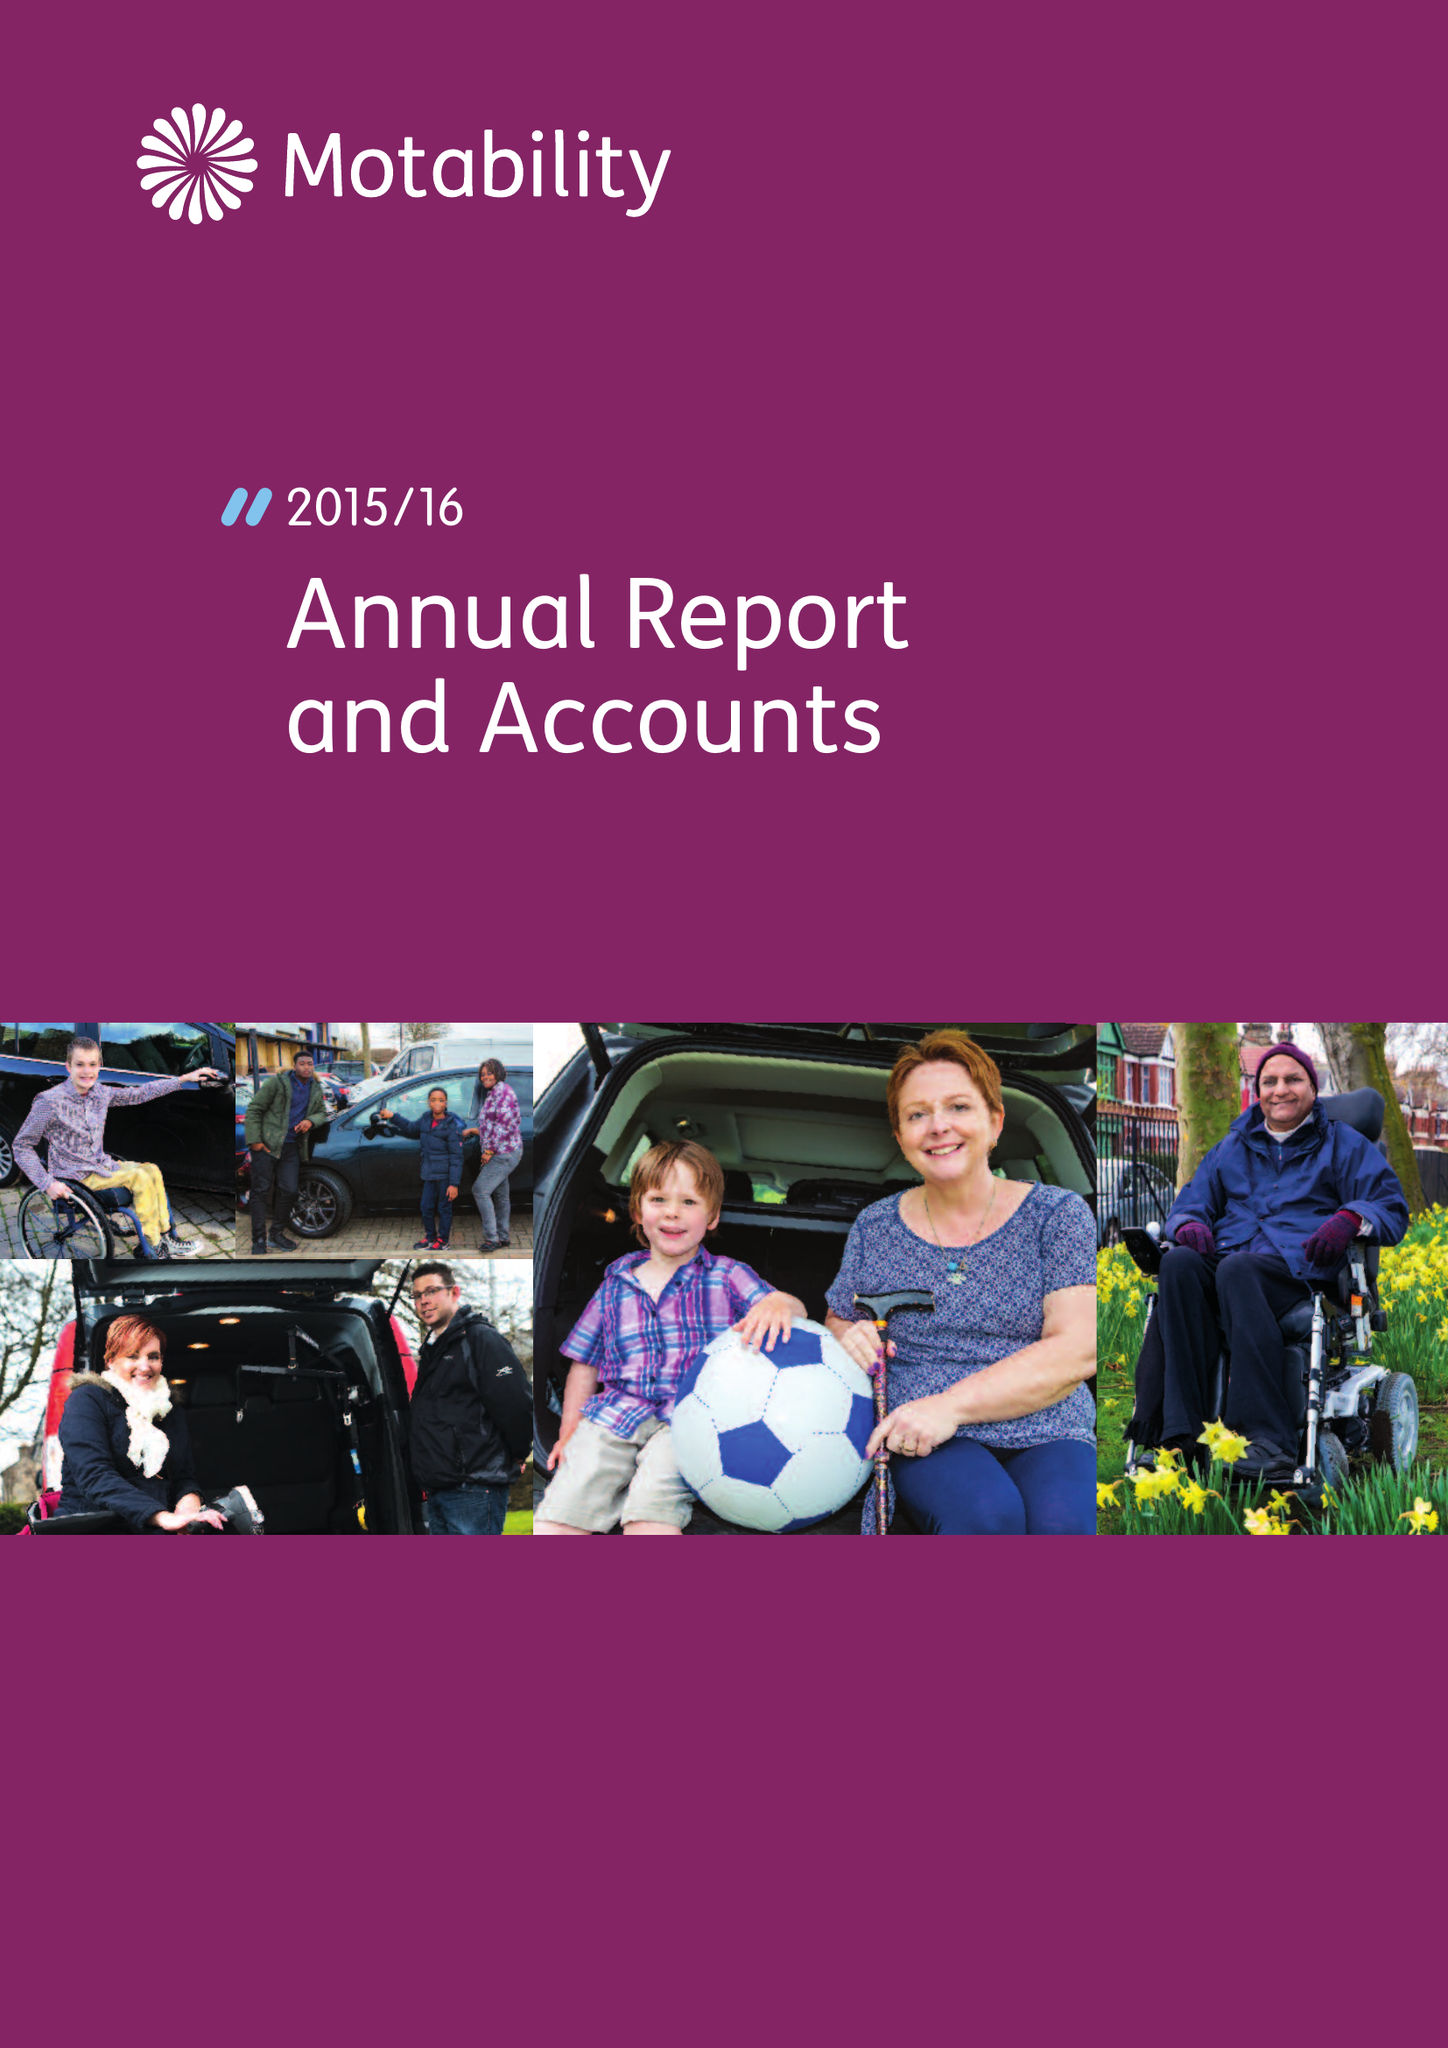What is the value for the charity_name?
Answer the question using a single word or phrase. Motability 